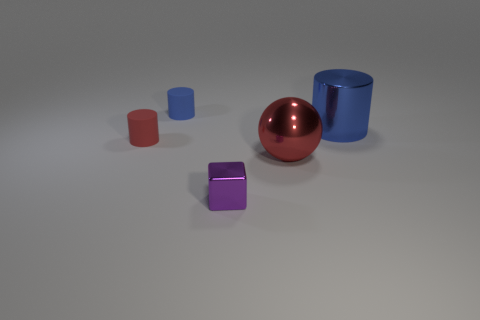There is a cylinder that is both in front of the blue matte cylinder and to the left of the red ball; what is its color? The cylinder that is positioned in front of the blue matte cylinder and to the left of the red ball is purple in color. 